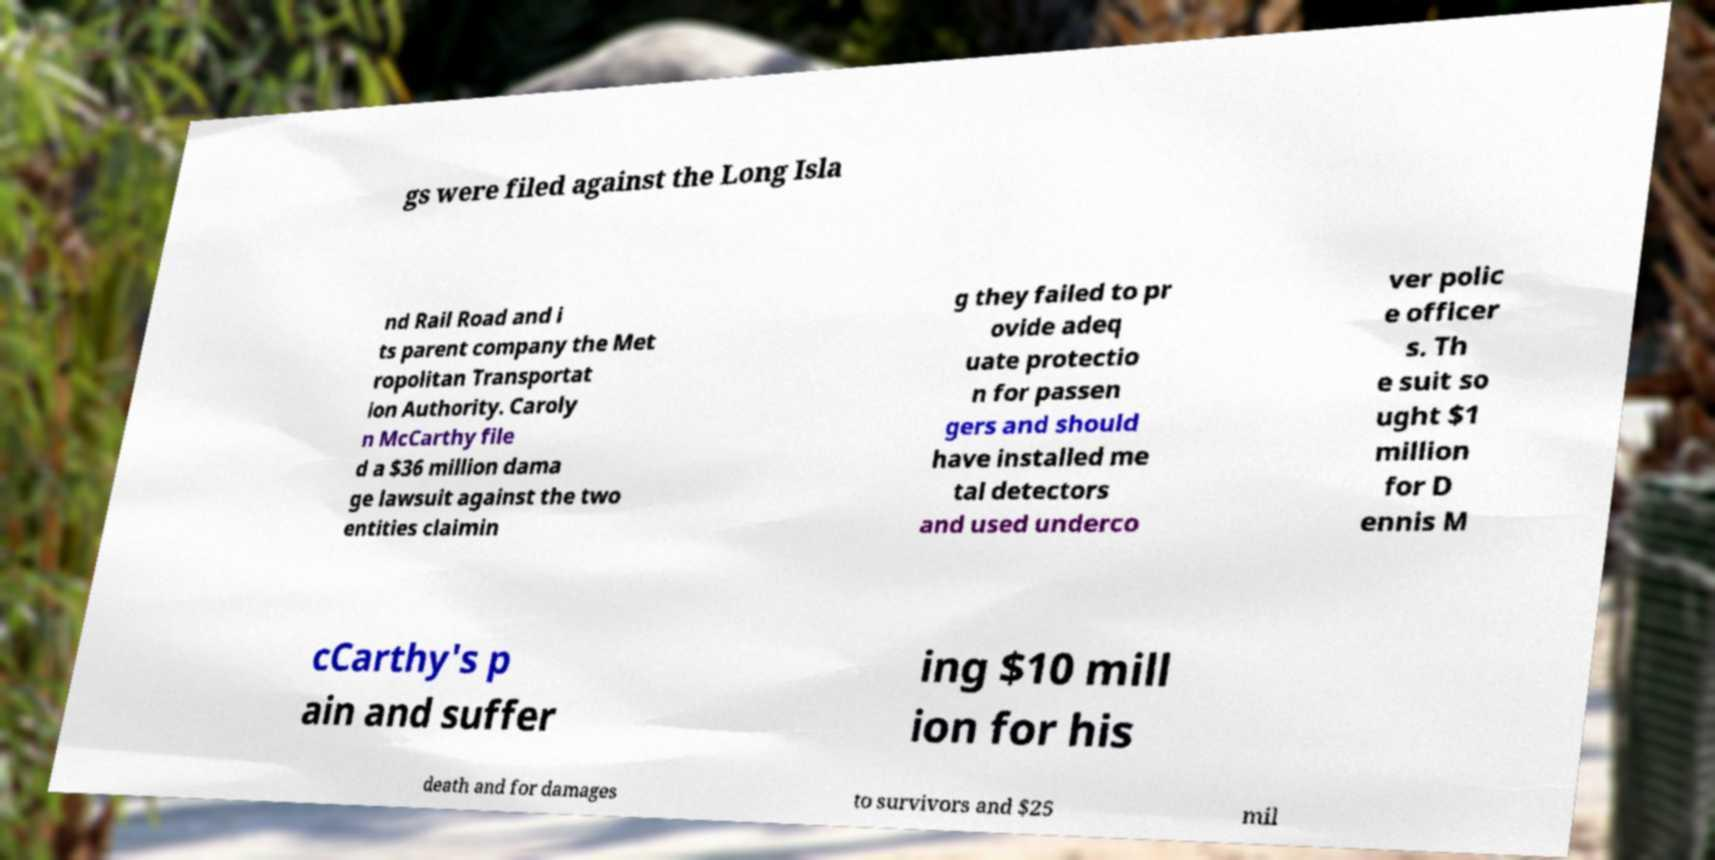For documentation purposes, I need the text within this image transcribed. Could you provide that? gs were filed against the Long Isla nd Rail Road and i ts parent company the Met ropolitan Transportat ion Authority. Caroly n McCarthy file d a $36 million dama ge lawsuit against the two entities claimin g they failed to pr ovide adeq uate protectio n for passen gers and should have installed me tal detectors and used underco ver polic e officer s. Th e suit so ught $1 million for D ennis M cCarthy's p ain and suffer ing $10 mill ion for his death and for damages to survivors and $25 mil 